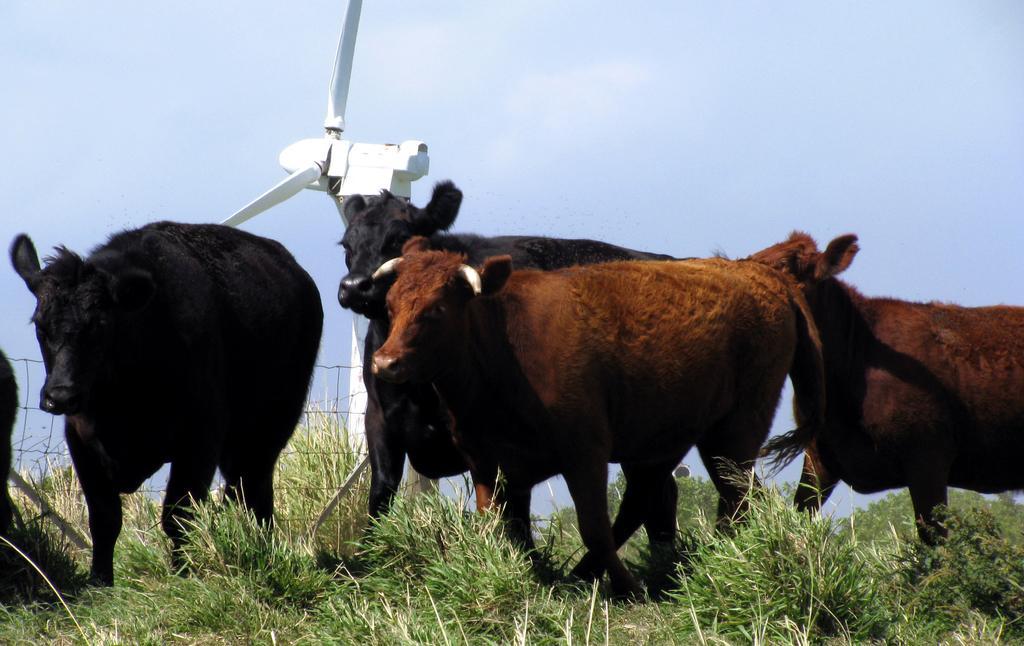Please provide a concise description of this image. In the image we can see there are animals standing on the ground and the ground is covered with grass. Behind there is a windmill and there is a clear sky. 